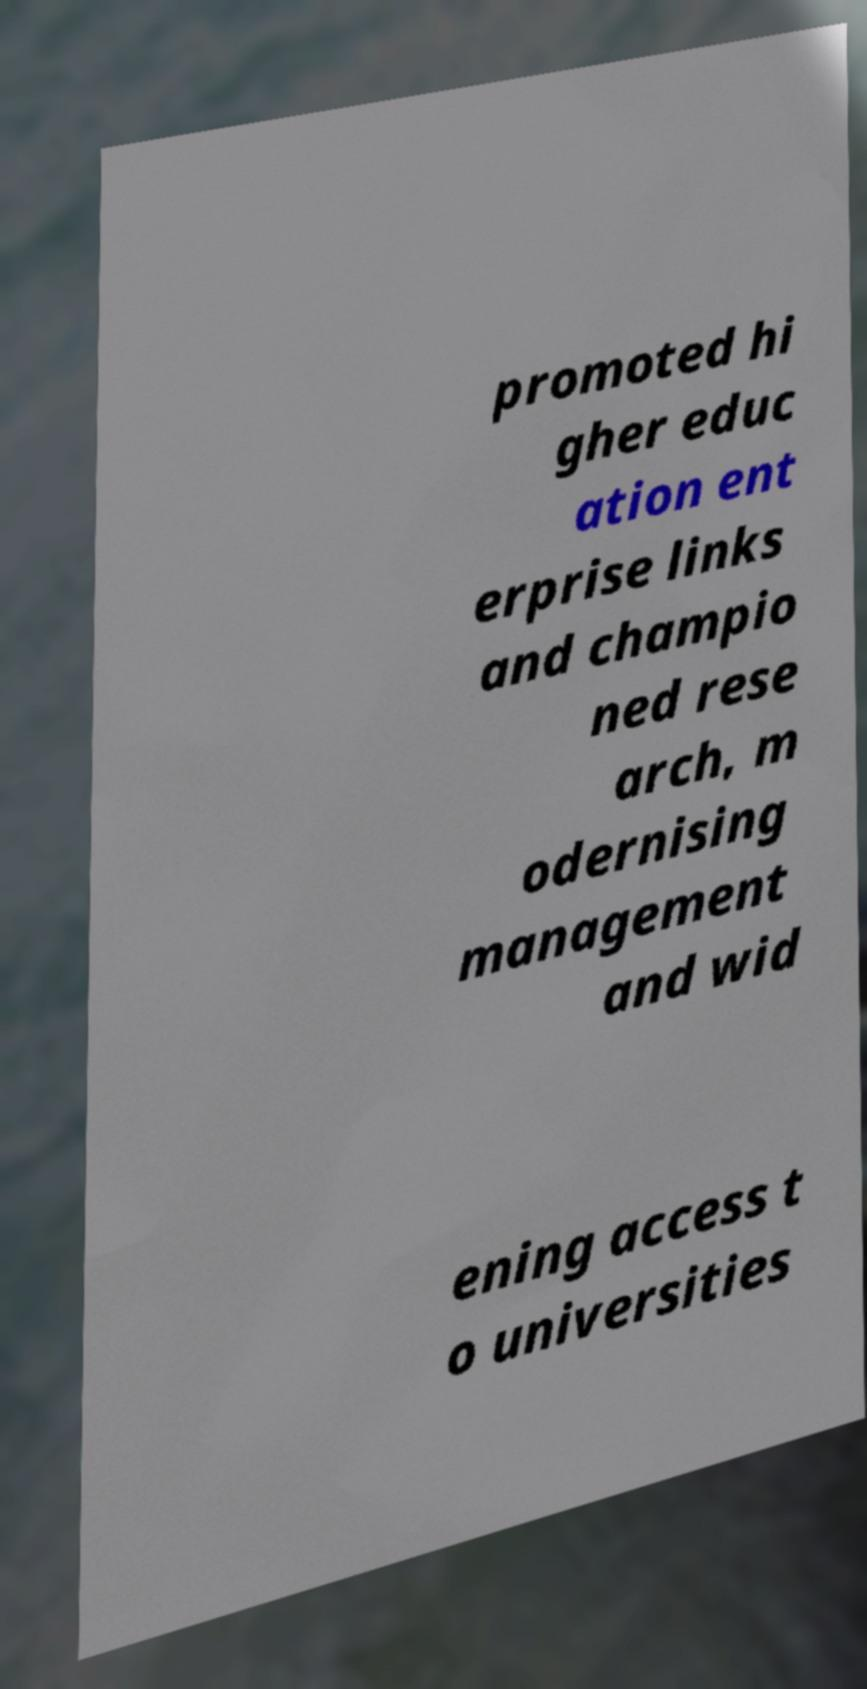Can you accurately transcribe the text from the provided image for me? promoted hi gher educ ation ent erprise links and champio ned rese arch, m odernising management and wid ening access t o universities 